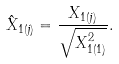<formula> <loc_0><loc_0><loc_500><loc_500>\hat { X } _ { 1 ( j ) } = \frac { X _ { 1 ( j ) } } { \sqrt { X _ { 1 ( 1 ) } ^ { 2 } } } .</formula> 